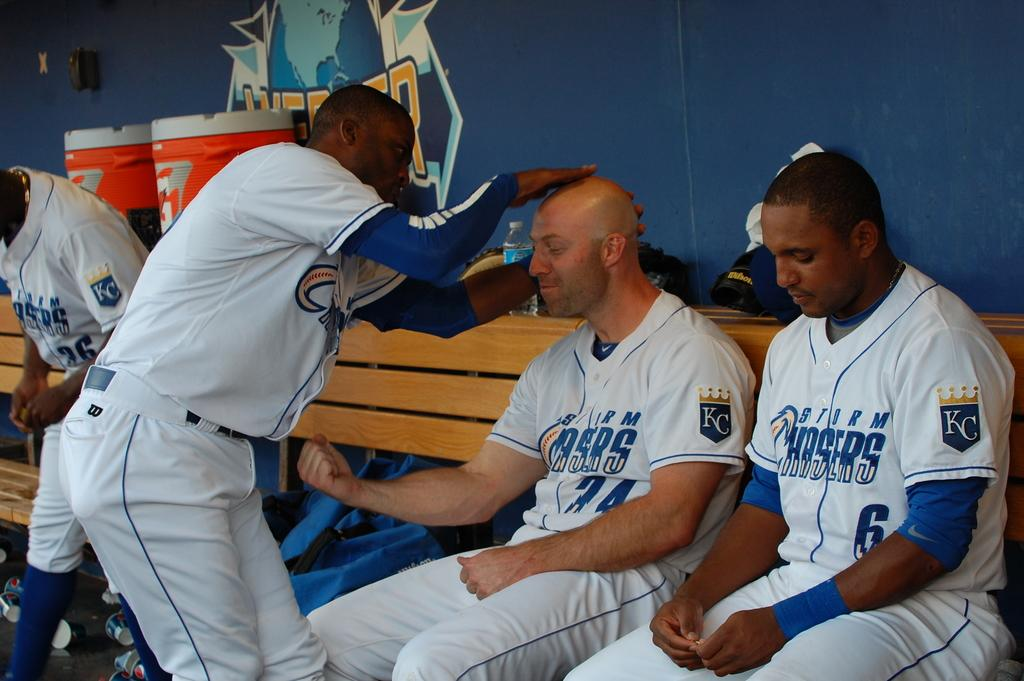<image>
Relay a brief, clear account of the picture shown. Two baseball players sitting in a dugout and another player patting one on the head. 